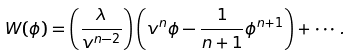Convert formula to latex. <formula><loc_0><loc_0><loc_500><loc_500>W ( \phi ) = \left ( \frac { \lambda } { v ^ { n - 2 } } \right ) \left ( v ^ { n } \phi - \frac { 1 } { n + 1 } \phi ^ { n + 1 } \right ) + \cdots .</formula> 